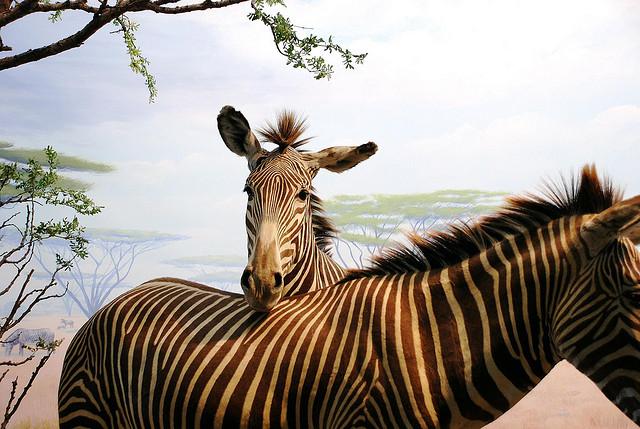How many zebras are in the scene?
Write a very short answer. 2. Is there a child in the picture?
Concise answer only. No. Are both animals looking in the same direction?
Write a very short answer. No. Are the zebras brown?
Write a very short answer. Yes. What is looking at you?
Be succinct. Zebra. 